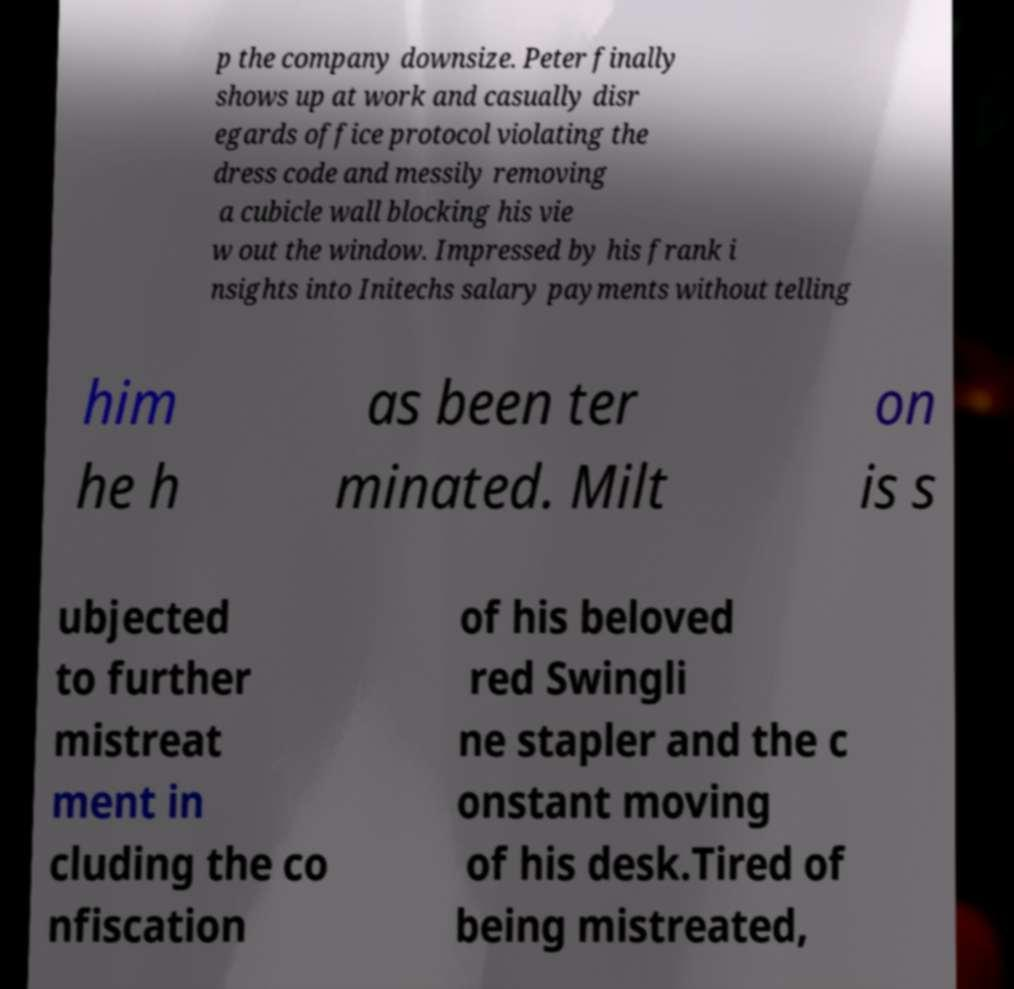Can you accurately transcribe the text from the provided image for me? p the company downsize. Peter finally shows up at work and casually disr egards office protocol violating the dress code and messily removing a cubicle wall blocking his vie w out the window. Impressed by his frank i nsights into Initechs salary payments without telling him he h as been ter minated. Milt on is s ubjected to further mistreat ment in cluding the co nfiscation of his beloved red Swingli ne stapler and the c onstant moving of his desk.Tired of being mistreated, 